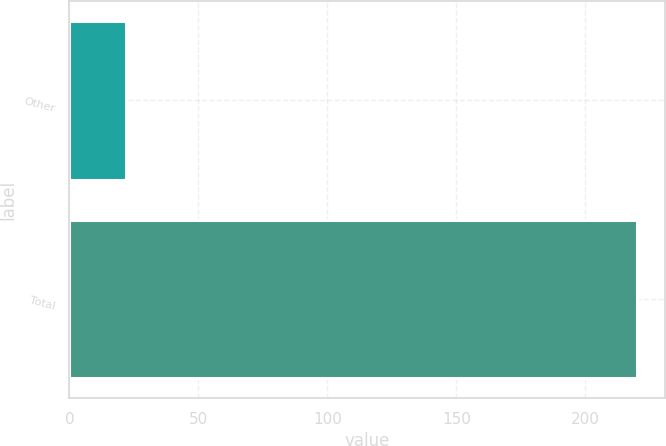<chart> <loc_0><loc_0><loc_500><loc_500><bar_chart><fcel>Other<fcel>Total<nl><fcel>22<fcel>220<nl></chart> 